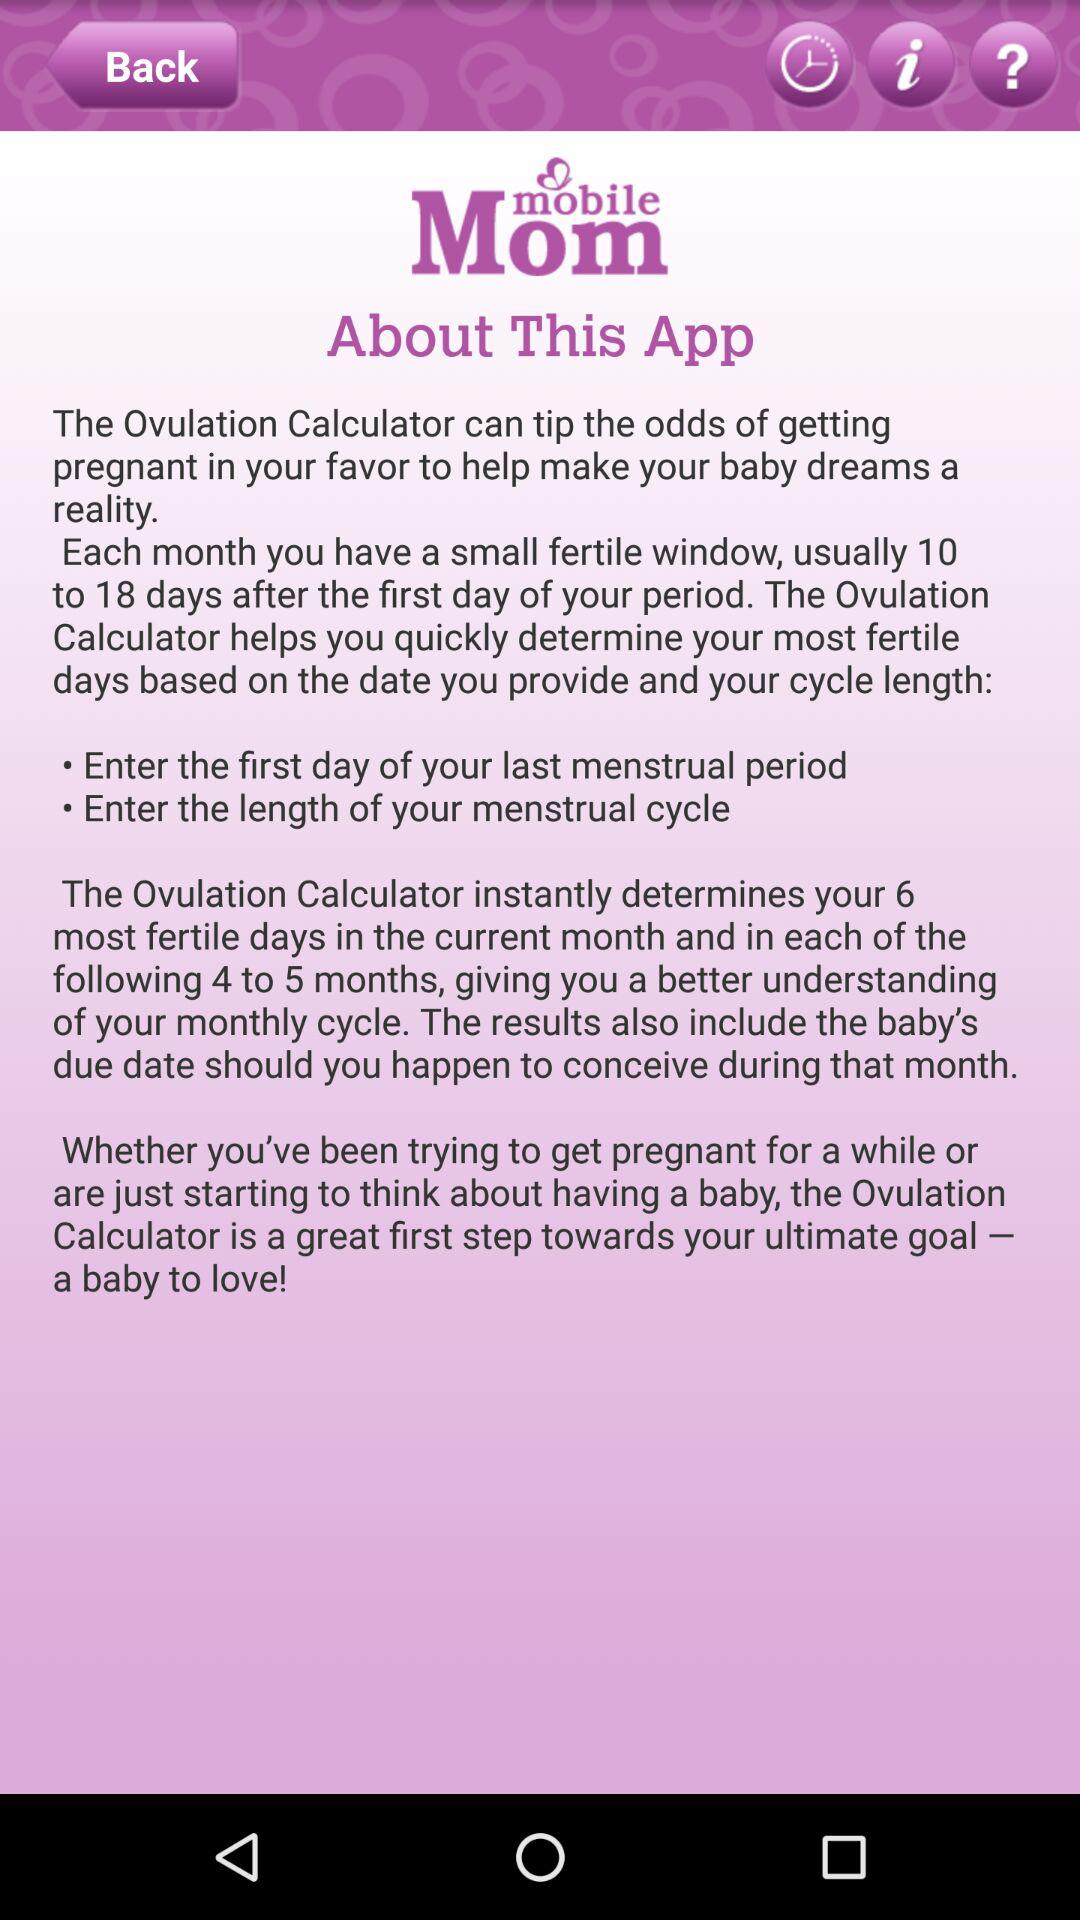How many days after the first day of your period is your fertile window?
Answer the question using a single word or phrase. 10 to 18 days 